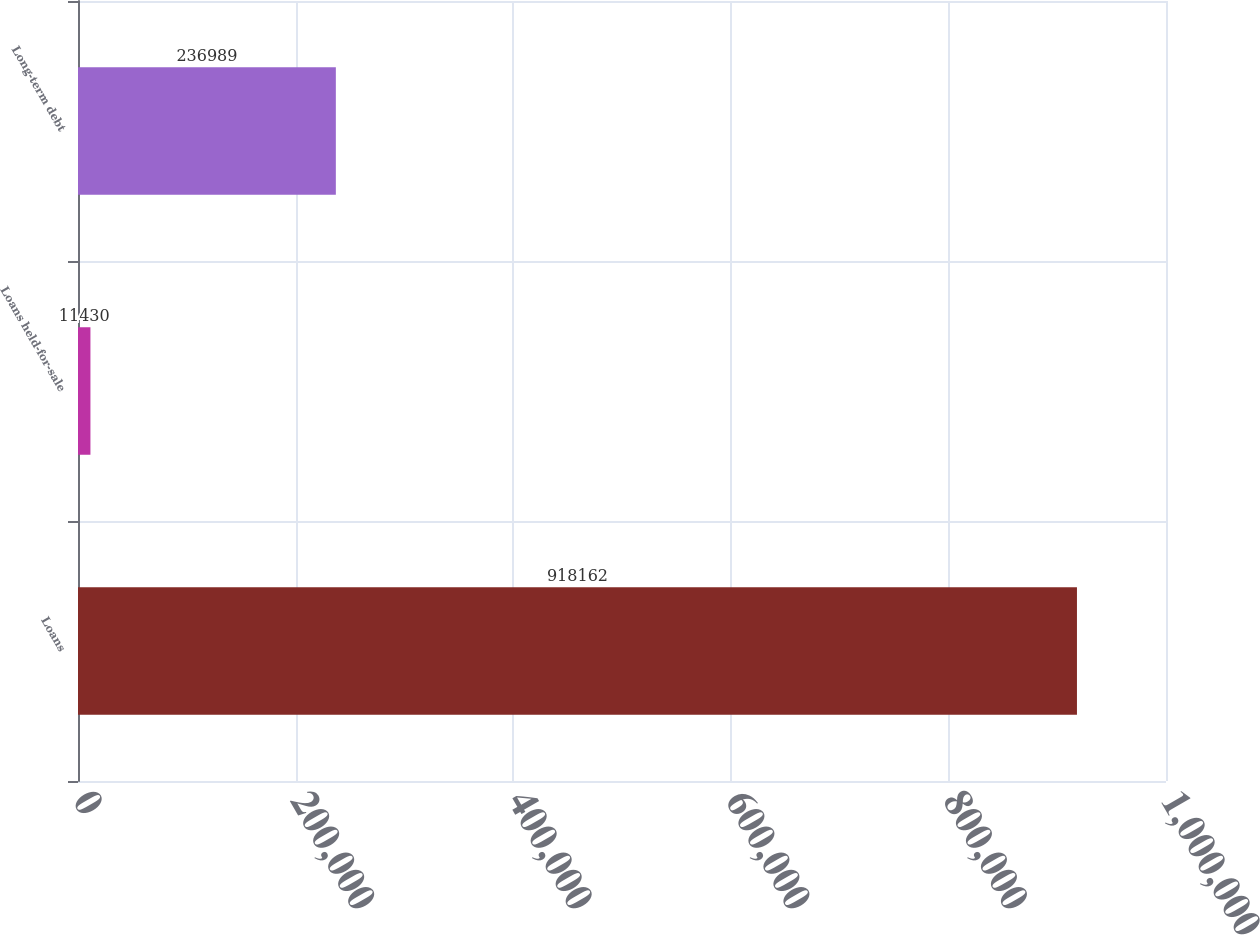Convert chart. <chart><loc_0><loc_0><loc_500><loc_500><bar_chart><fcel>Loans<fcel>Loans held-for-sale<fcel>Long-term debt<nl><fcel>918162<fcel>11430<fcel>236989<nl></chart> 